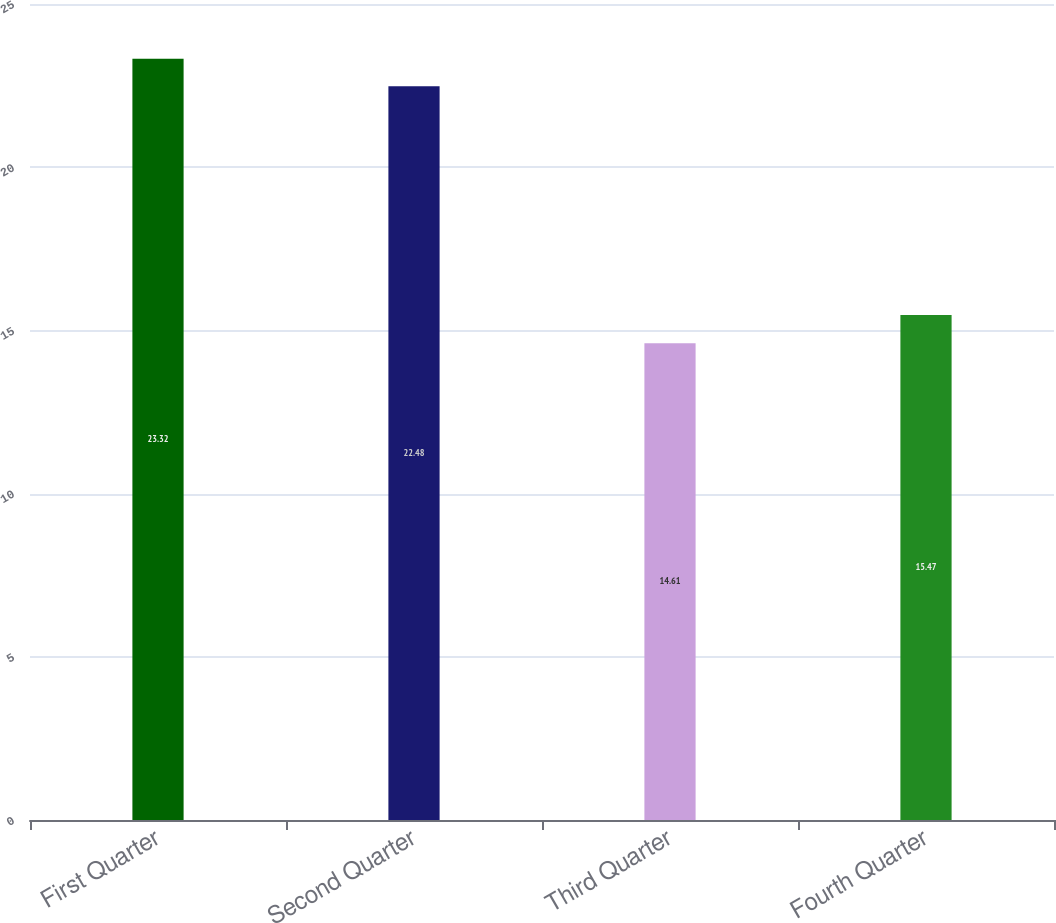<chart> <loc_0><loc_0><loc_500><loc_500><bar_chart><fcel>First Quarter<fcel>Second Quarter<fcel>Third Quarter<fcel>Fourth Quarter<nl><fcel>23.32<fcel>22.48<fcel>14.61<fcel>15.47<nl></chart> 